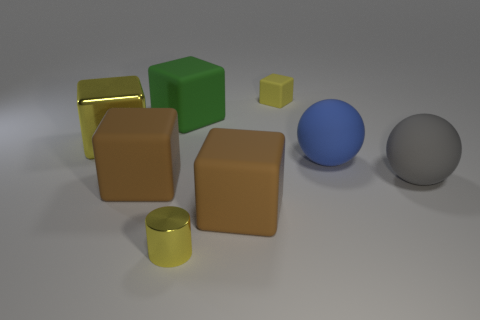Subtract all large rubber cubes. How many cubes are left? 2 Add 1 metal things. How many objects exist? 9 Subtract all yellow cubes. How many cubes are left? 3 Subtract all spheres. How many objects are left? 6 Subtract all blue spheres. How many brown blocks are left? 2 Subtract 1 cylinders. How many cylinders are left? 0 Subtract all blue cylinders. Subtract all brown balls. How many cylinders are left? 1 Subtract all large yellow shiny cylinders. Subtract all large gray matte spheres. How many objects are left? 7 Add 8 yellow metal blocks. How many yellow metal blocks are left? 9 Add 8 big shiny things. How many big shiny things exist? 9 